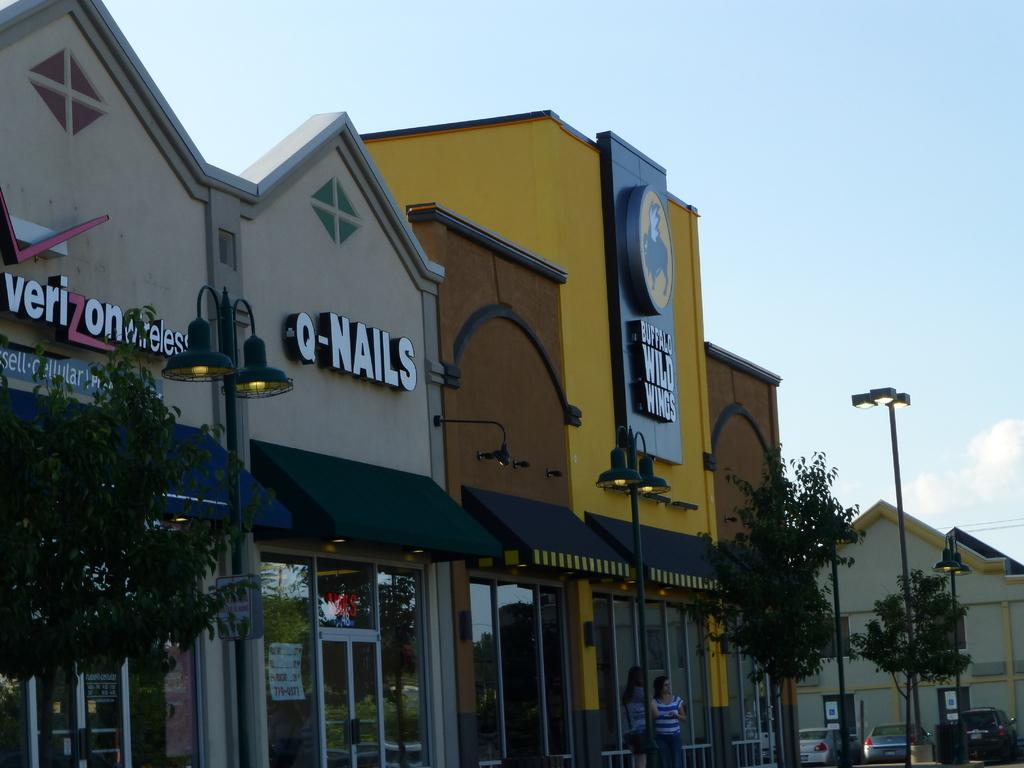What type of structures can be seen in the image? There are buildings in the image. What other natural elements are present in the image? There are trees in the image. What is happening on the road in the image? Cars are moving on the road in the image. What is the condition of the sky in the image? The sky is clear in the image. Can you see the ground on the face of the building in the image? There is no mention of a face on a building in the image, and the ground is not visible on any part of the buildings. How many bites have been taken out of the trees in the image? There is no indication of any bites taken out of the trees in the image; they appear to be intact. 